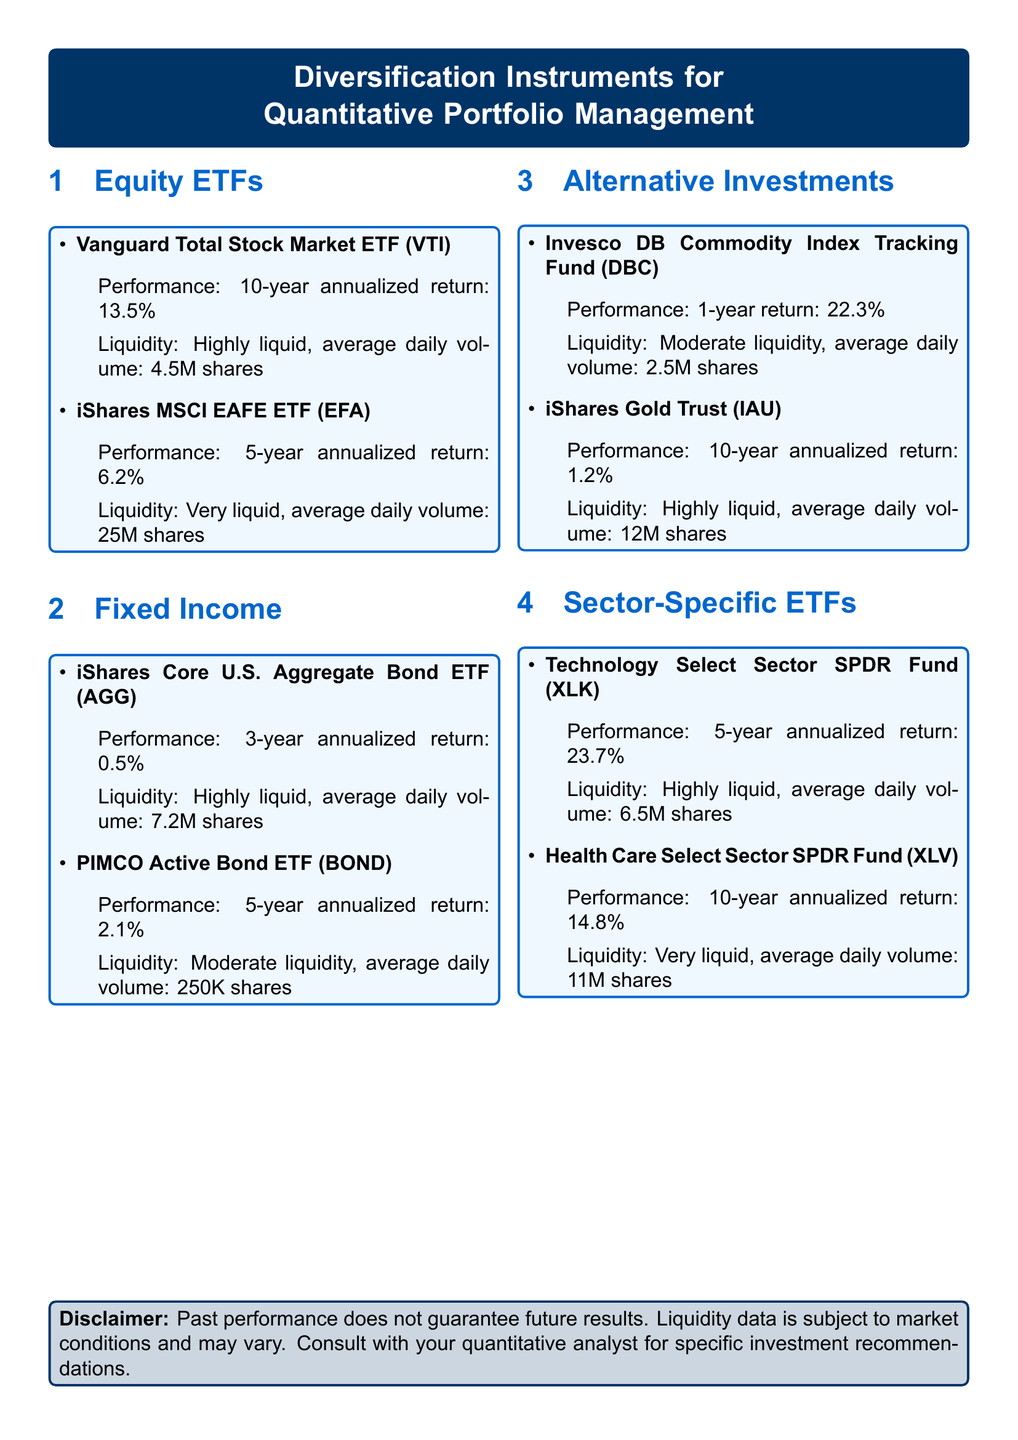What is the 10-year annualized return for Vanguard Total Stock Market ETF? The 10-year annualized return is explicitly stated for Vanguard Total Stock Market ETF in the document.
Answer: 13.5% What is the average daily volume for iShares MSCI EAFE ETF? The average daily volume is provided in the liquidity section for iShares MSCI EAFE ETF.
Answer: 25M shares Which ETF has the highest 5-year annualized return among sector-specific ETFs? The sector-specific ETFs section lists the annualized returns, and comparing them shows which ETF has the highest return.
Answer: Technology Select Sector SPDR Fund (XLK) What is the liquidity classification for PIMCO Active Bond ETF? The liquidity classification is mentioned in the performance section of PIMCO Active Bond ETF.
Answer: Moderate liquidity What is the 1-year return for Invesco DB Commodity Index Tracking Fund? The 1-year return is provided in the alternative investments section.
Answer: 22.3% What instrument has an average daily volume of 6.5M shares? The average daily volume is noted in the sector-specific ETFs section and can identify which instrument matches that volume.
Answer: Technology Select Sector SPDR Fund (XLK) What is the annualized return for iShares Gold Trust over 10 years? The document states the performance data for iShares Gold Trust specifically.
Answer: 1.2% Which financial instrument has the lowest annualized return in the fixed income section? By analyzing all returns listed in the fixed income section, the instrument with the lowest return can be identified.
Answer: iShares Core U.S. Aggregate Bond ETF (AGG) What type of financial instruments are found in the catalog? The catalog encompasses various types of financial instruments as categorized in the document.
Answer: Equity ETFs, Fixed Income, Alternative Investments, Sector-Specific ETFs 